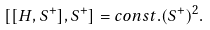<formula> <loc_0><loc_0><loc_500><loc_500>[ [ H , S ^ { + } ] , S ^ { + } ] = c o n s t . ( S ^ { + } ) ^ { 2 } .</formula> 